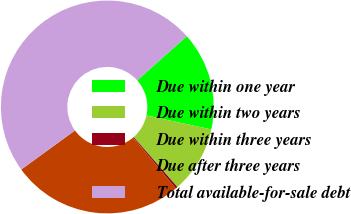<chart> <loc_0><loc_0><loc_500><loc_500><pie_chart><fcel>Due within one year<fcel>Due within two years<fcel>Due within three years<fcel>Due after three years<fcel>Total available-for-sale debt<nl><fcel>14.98%<fcel>10.17%<fcel>0.32%<fcel>26.12%<fcel>48.42%<nl></chart> 